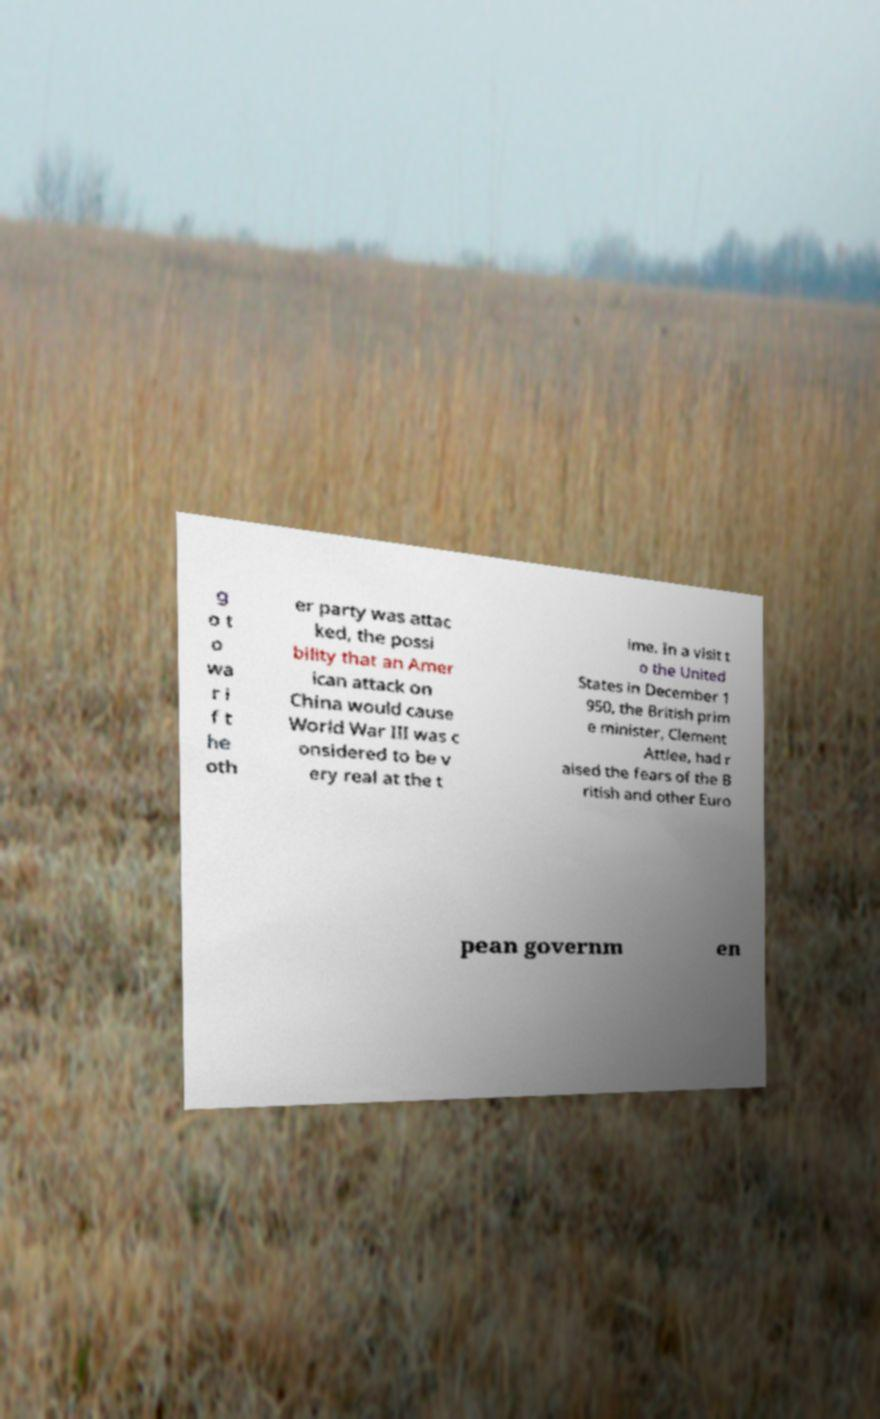Please read and relay the text visible in this image. What does it say? g o t o wa r i f t he oth er party was attac ked, the possi bility that an Amer ican attack on China would cause World War III was c onsidered to be v ery real at the t ime. In a visit t o the United States in December 1 950, the British prim e minister, Clement Attlee, had r aised the fears of the B ritish and other Euro pean governm en 